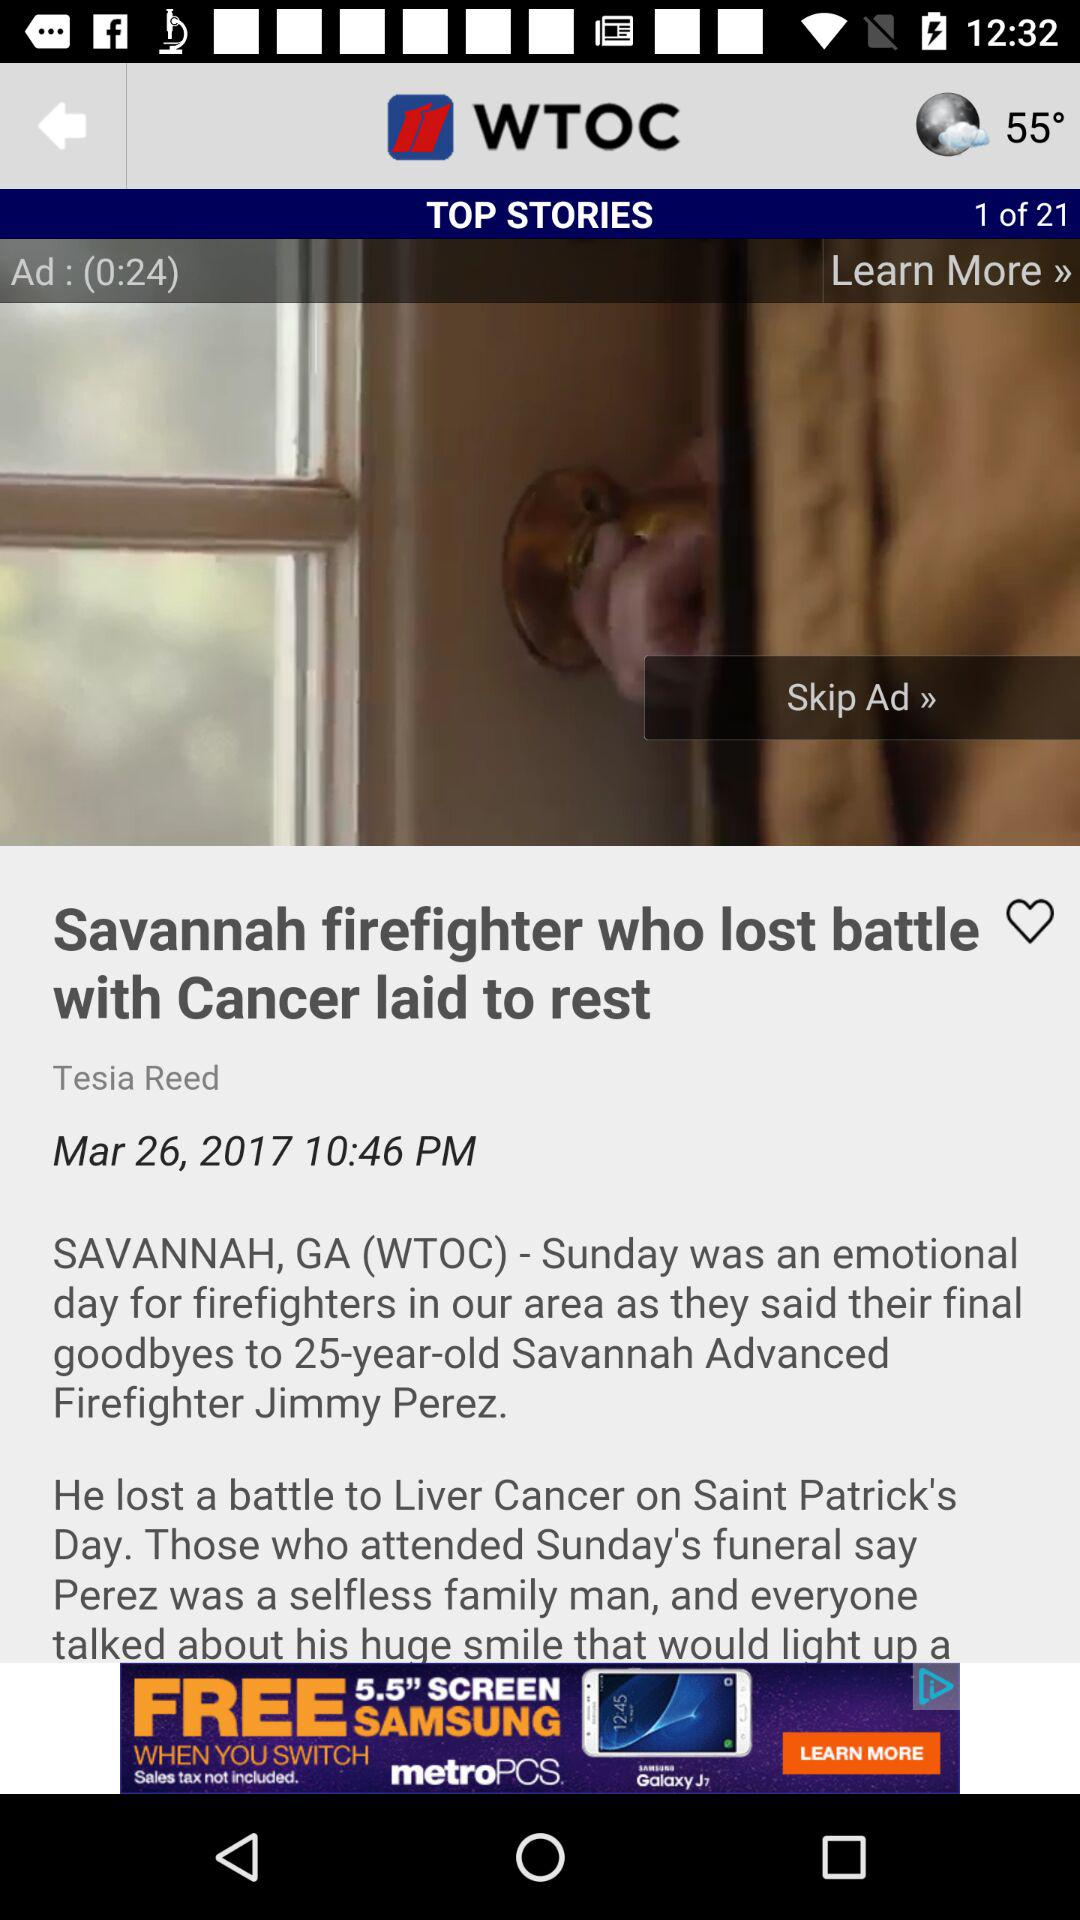What is the advertisement duration? The duration of the advertisement is 24 seconds. 